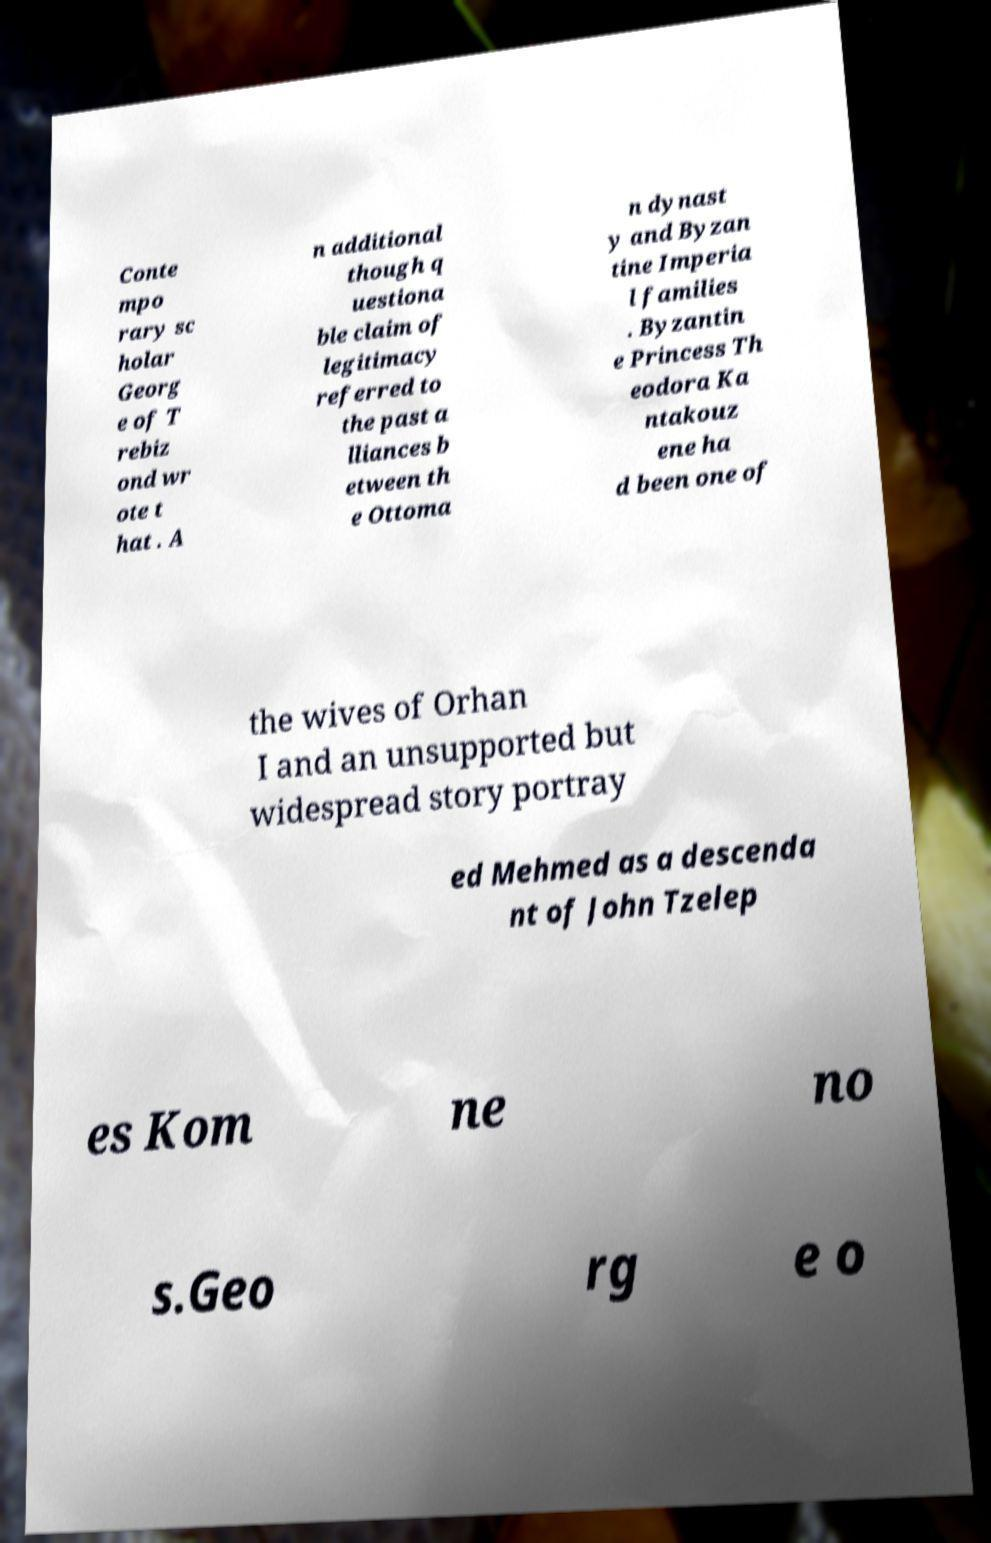There's text embedded in this image that I need extracted. Can you transcribe it verbatim? Conte mpo rary sc holar Georg e of T rebiz ond wr ote t hat . A n additional though q uestiona ble claim of legitimacy referred to the past a lliances b etween th e Ottoma n dynast y and Byzan tine Imperia l families . Byzantin e Princess Th eodora Ka ntakouz ene ha d been one of the wives of Orhan I and an unsupported but widespread story portray ed Mehmed as a descenda nt of John Tzelep es Kom ne no s.Geo rg e o 